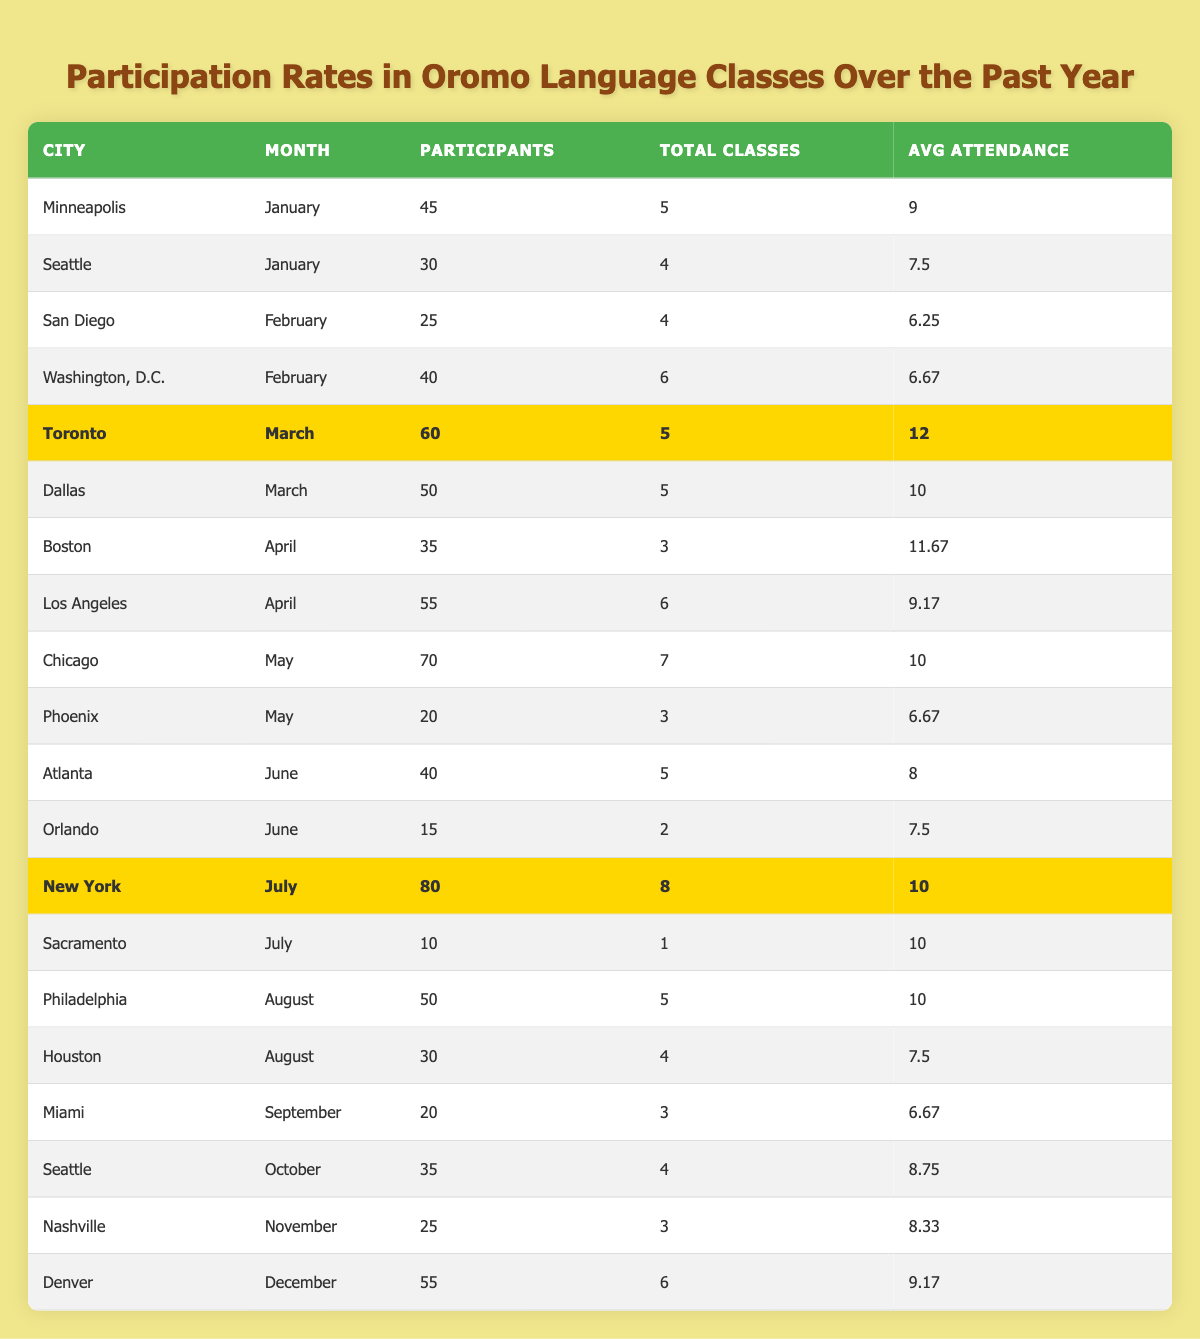What was the highest participation rate in a single month for any city? Reviewing the table, the highest participation occurred in New York in July with 80 participants.
Answer: 80 Which city had the lowest participation rate overall? The city with the lowest participation was Sacramento in July, with only 10 participants.
Answer: Sacramento What is the average attendance for Toronto's Oromo language classes? In March, Toronto had an average attendance of 12 based on 60 participants in 5 classes.
Answer: 12 How many participants attended Omaha's Oromo classes in February? Omaha was not mentioned in the table data; hence, there were no participants for Omaha.
Answer: 0 What is the total number of participants across all classes in January? Minneapolis had 45 participants and Seattle had 30, summing to 45 + 30 = 75 participants in January.
Answer: 75 In which month did Chicago have the highest number of participants? Chicago had the highest participation of 70 in May, which is greater than its December, February, or any other month.
Answer: May What is the average attendance in classes held in August? In August, Philadelphia had 50 participants across 5 classes giving an average of 10, while Houston had 30 participants for 4 classes, averaging 7.5, so average attendance is (10 + 7.5) / 2 = 8.75.
Answer: 8.75 How many total classes were held in Washington, D.C. in February? In February, Washington, D.C. conducted a total of 6 classes.
Answer: 6 What is the difference in participants between New York and Nashville in November? New York had 80 participants in July, and Nashville had 25 in November. The difference is 80 - 25 = 55 participants.
Answer: 55 Was the average attendance in June higher than in July? In June, the average attendance was 8 (40 participants over 5 classes in Atlanta, plus 15 over 2 in Orlando), while in July it was 10 based on New York's data. Therefore, June's average attendance was lower.
Answer: No 